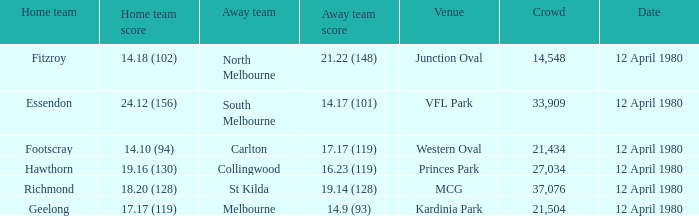Who was North Melbourne's home opponent? Fitzroy. 